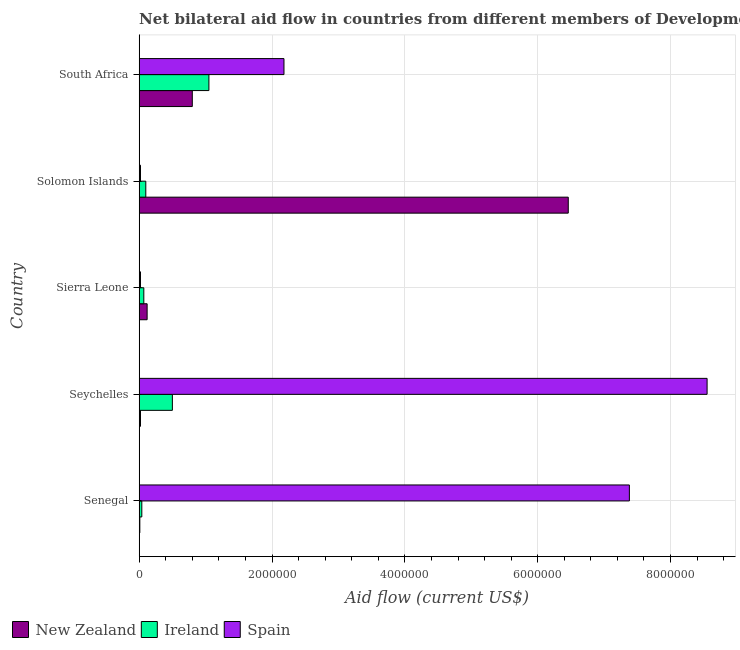How many different coloured bars are there?
Make the answer very short. 3. How many groups of bars are there?
Make the answer very short. 5. Are the number of bars per tick equal to the number of legend labels?
Provide a succinct answer. Yes. How many bars are there on the 4th tick from the bottom?
Provide a short and direct response. 3. What is the label of the 5th group of bars from the top?
Provide a short and direct response. Senegal. In how many cases, is the number of bars for a given country not equal to the number of legend labels?
Offer a terse response. 0. What is the amount of aid provided by new zealand in South Africa?
Your answer should be compact. 8.00e+05. Across all countries, what is the maximum amount of aid provided by new zealand?
Your answer should be very brief. 6.46e+06. Across all countries, what is the minimum amount of aid provided by new zealand?
Your answer should be compact. 10000. In which country was the amount of aid provided by spain maximum?
Give a very brief answer. Seychelles. In which country was the amount of aid provided by new zealand minimum?
Your answer should be compact. Senegal. What is the total amount of aid provided by spain in the graph?
Provide a succinct answer. 1.82e+07. What is the difference between the amount of aid provided by spain in Seychelles and that in Solomon Islands?
Offer a terse response. 8.53e+06. What is the difference between the amount of aid provided by new zealand in Seychelles and the amount of aid provided by spain in Sierra Leone?
Give a very brief answer. 0. What is the average amount of aid provided by ireland per country?
Your response must be concise. 3.52e+05. What is the difference between the amount of aid provided by ireland and amount of aid provided by new zealand in Solomon Islands?
Your answer should be very brief. -6.36e+06. In how many countries, is the amount of aid provided by new zealand greater than 6000000 US$?
Give a very brief answer. 1. What is the ratio of the amount of aid provided by spain in Senegal to that in Sierra Leone?
Your answer should be very brief. 369. Is the amount of aid provided by spain in Senegal less than that in South Africa?
Your answer should be very brief. No. Is the difference between the amount of aid provided by ireland in Senegal and Sierra Leone greater than the difference between the amount of aid provided by spain in Senegal and Sierra Leone?
Your response must be concise. No. What is the difference between the highest and the lowest amount of aid provided by ireland?
Provide a succinct answer. 1.01e+06. In how many countries, is the amount of aid provided by new zealand greater than the average amount of aid provided by new zealand taken over all countries?
Your answer should be compact. 1. What does the 1st bar from the top in Senegal represents?
Offer a terse response. Spain. What does the 1st bar from the bottom in Senegal represents?
Your answer should be compact. New Zealand. Is it the case that in every country, the sum of the amount of aid provided by new zealand and amount of aid provided by ireland is greater than the amount of aid provided by spain?
Offer a terse response. No. How many bars are there?
Provide a short and direct response. 15. Are all the bars in the graph horizontal?
Your response must be concise. Yes. How many countries are there in the graph?
Your answer should be compact. 5. What is the difference between two consecutive major ticks on the X-axis?
Offer a terse response. 2.00e+06. Are the values on the major ticks of X-axis written in scientific E-notation?
Make the answer very short. No. Where does the legend appear in the graph?
Keep it short and to the point. Bottom left. How are the legend labels stacked?
Your response must be concise. Horizontal. What is the title of the graph?
Provide a short and direct response. Net bilateral aid flow in countries from different members of Development Assistance Committee. Does "Ores and metals" appear as one of the legend labels in the graph?
Your answer should be very brief. No. What is the label or title of the X-axis?
Provide a short and direct response. Aid flow (current US$). What is the label or title of the Y-axis?
Your answer should be compact. Country. What is the Aid flow (current US$) in Spain in Senegal?
Make the answer very short. 7.38e+06. What is the Aid flow (current US$) in Ireland in Seychelles?
Your answer should be very brief. 5.00e+05. What is the Aid flow (current US$) in Spain in Seychelles?
Your answer should be very brief. 8.55e+06. What is the Aid flow (current US$) of New Zealand in Sierra Leone?
Offer a terse response. 1.20e+05. What is the Aid flow (current US$) of New Zealand in Solomon Islands?
Provide a short and direct response. 6.46e+06. What is the Aid flow (current US$) in Spain in Solomon Islands?
Your answer should be very brief. 2.00e+04. What is the Aid flow (current US$) in New Zealand in South Africa?
Make the answer very short. 8.00e+05. What is the Aid flow (current US$) of Ireland in South Africa?
Your answer should be very brief. 1.05e+06. What is the Aid flow (current US$) of Spain in South Africa?
Your answer should be very brief. 2.18e+06. Across all countries, what is the maximum Aid flow (current US$) of New Zealand?
Your response must be concise. 6.46e+06. Across all countries, what is the maximum Aid flow (current US$) in Ireland?
Your answer should be very brief. 1.05e+06. Across all countries, what is the maximum Aid flow (current US$) in Spain?
Give a very brief answer. 8.55e+06. Across all countries, what is the minimum Aid flow (current US$) of New Zealand?
Keep it short and to the point. 10000. Across all countries, what is the minimum Aid flow (current US$) of Ireland?
Provide a short and direct response. 4.00e+04. What is the total Aid flow (current US$) of New Zealand in the graph?
Make the answer very short. 7.41e+06. What is the total Aid flow (current US$) in Ireland in the graph?
Provide a succinct answer. 1.76e+06. What is the total Aid flow (current US$) in Spain in the graph?
Keep it short and to the point. 1.82e+07. What is the difference between the Aid flow (current US$) in Ireland in Senegal and that in Seychelles?
Your response must be concise. -4.60e+05. What is the difference between the Aid flow (current US$) in Spain in Senegal and that in Seychelles?
Give a very brief answer. -1.17e+06. What is the difference between the Aid flow (current US$) of Ireland in Senegal and that in Sierra Leone?
Your answer should be compact. -3.00e+04. What is the difference between the Aid flow (current US$) in Spain in Senegal and that in Sierra Leone?
Provide a short and direct response. 7.36e+06. What is the difference between the Aid flow (current US$) in New Zealand in Senegal and that in Solomon Islands?
Your answer should be compact. -6.45e+06. What is the difference between the Aid flow (current US$) in Spain in Senegal and that in Solomon Islands?
Give a very brief answer. 7.36e+06. What is the difference between the Aid flow (current US$) in New Zealand in Senegal and that in South Africa?
Make the answer very short. -7.90e+05. What is the difference between the Aid flow (current US$) of Ireland in Senegal and that in South Africa?
Ensure brevity in your answer.  -1.01e+06. What is the difference between the Aid flow (current US$) of Spain in Senegal and that in South Africa?
Offer a very short reply. 5.20e+06. What is the difference between the Aid flow (current US$) of New Zealand in Seychelles and that in Sierra Leone?
Make the answer very short. -1.00e+05. What is the difference between the Aid flow (current US$) in Spain in Seychelles and that in Sierra Leone?
Ensure brevity in your answer.  8.53e+06. What is the difference between the Aid flow (current US$) of New Zealand in Seychelles and that in Solomon Islands?
Your answer should be very brief. -6.44e+06. What is the difference between the Aid flow (current US$) of Ireland in Seychelles and that in Solomon Islands?
Offer a terse response. 4.00e+05. What is the difference between the Aid flow (current US$) in Spain in Seychelles and that in Solomon Islands?
Provide a short and direct response. 8.53e+06. What is the difference between the Aid flow (current US$) in New Zealand in Seychelles and that in South Africa?
Your response must be concise. -7.80e+05. What is the difference between the Aid flow (current US$) in Ireland in Seychelles and that in South Africa?
Make the answer very short. -5.50e+05. What is the difference between the Aid flow (current US$) of Spain in Seychelles and that in South Africa?
Provide a short and direct response. 6.37e+06. What is the difference between the Aid flow (current US$) of New Zealand in Sierra Leone and that in Solomon Islands?
Make the answer very short. -6.34e+06. What is the difference between the Aid flow (current US$) in Spain in Sierra Leone and that in Solomon Islands?
Your answer should be compact. 0. What is the difference between the Aid flow (current US$) in New Zealand in Sierra Leone and that in South Africa?
Your answer should be very brief. -6.80e+05. What is the difference between the Aid flow (current US$) in Ireland in Sierra Leone and that in South Africa?
Your answer should be very brief. -9.80e+05. What is the difference between the Aid flow (current US$) of Spain in Sierra Leone and that in South Africa?
Make the answer very short. -2.16e+06. What is the difference between the Aid flow (current US$) in New Zealand in Solomon Islands and that in South Africa?
Offer a very short reply. 5.66e+06. What is the difference between the Aid flow (current US$) of Ireland in Solomon Islands and that in South Africa?
Your answer should be very brief. -9.50e+05. What is the difference between the Aid flow (current US$) in Spain in Solomon Islands and that in South Africa?
Provide a succinct answer. -2.16e+06. What is the difference between the Aid flow (current US$) in New Zealand in Senegal and the Aid flow (current US$) in Ireland in Seychelles?
Provide a succinct answer. -4.90e+05. What is the difference between the Aid flow (current US$) in New Zealand in Senegal and the Aid flow (current US$) in Spain in Seychelles?
Ensure brevity in your answer.  -8.54e+06. What is the difference between the Aid flow (current US$) in Ireland in Senegal and the Aid flow (current US$) in Spain in Seychelles?
Ensure brevity in your answer.  -8.51e+06. What is the difference between the Aid flow (current US$) of New Zealand in Senegal and the Aid flow (current US$) of Ireland in Sierra Leone?
Your response must be concise. -6.00e+04. What is the difference between the Aid flow (current US$) of New Zealand in Senegal and the Aid flow (current US$) of Spain in Sierra Leone?
Your response must be concise. -10000. What is the difference between the Aid flow (current US$) in New Zealand in Senegal and the Aid flow (current US$) in Ireland in Solomon Islands?
Your response must be concise. -9.00e+04. What is the difference between the Aid flow (current US$) of New Zealand in Senegal and the Aid flow (current US$) of Ireland in South Africa?
Your answer should be very brief. -1.04e+06. What is the difference between the Aid flow (current US$) of New Zealand in Senegal and the Aid flow (current US$) of Spain in South Africa?
Your answer should be compact. -2.17e+06. What is the difference between the Aid flow (current US$) of Ireland in Senegal and the Aid flow (current US$) of Spain in South Africa?
Make the answer very short. -2.14e+06. What is the difference between the Aid flow (current US$) in New Zealand in Seychelles and the Aid flow (current US$) in Spain in Sierra Leone?
Make the answer very short. 0. What is the difference between the Aid flow (current US$) of New Zealand in Seychelles and the Aid flow (current US$) of Spain in Solomon Islands?
Make the answer very short. 0. What is the difference between the Aid flow (current US$) in Ireland in Seychelles and the Aid flow (current US$) in Spain in Solomon Islands?
Offer a very short reply. 4.80e+05. What is the difference between the Aid flow (current US$) in New Zealand in Seychelles and the Aid flow (current US$) in Ireland in South Africa?
Provide a succinct answer. -1.03e+06. What is the difference between the Aid flow (current US$) of New Zealand in Seychelles and the Aid flow (current US$) of Spain in South Africa?
Your answer should be compact. -2.16e+06. What is the difference between the Aid flow (current US$) of Ireland in Seychelles and the Aid flow (current US$) of Spain in South Africa?
Your answer should be very brief. -1.68e+06. What is the difference between the Aid flow (current US$) in New Zealand in Sierra Leone and the Aid flow (current US$) in Ireland in Solomon Islands?
Offer a terse response. 2.00e+04. What is the difference between the Aid flow (current US$) in New Zealand in Sierra Leone and the Aid flow (current US$) in Spain in Solomon Islands?
Your response must be concise. 1.00e+05. What is the difference between the Aid flow (current US$) in Ireland in Sierra Leone and the Aid flow (current US$) in Spain in Solomon Islands?
Ensure brevity in your answer.  5.00e+04. What is the difference between the Aid flow (current US$) of New Zealand in Sierra Leone and the Aid flow (current US$) of Ireland in South Africa?
Keep it short and to the point. -9.30e+05. What is the difference between the Aid flow (current US$) in New Zealand in Sierra Leone and the Aid flow (current US$) in Spain in South Africa?
Provide a succinct answer. -2.06e+06. What is the difference between the Aid flow (current US$) in Ireland in Sierra Leone and the Aid flow (current US$) in Spain in South Africa?
Offer a very short reply. -2.11e+06. What is the difference between the Aid flow (current US$) in New Zealand in Solomon Islands and the Aid flow (current US$) in Ireland in South Africa?
Give a very brief answer. 5.41e+06. What is the difference between the Aid flow (current US$) of New Zealand in Solomon Islands and the Aid flow (current US$) of Spain in South Africa?
Offer a very short reply. 4.28e+06. What is the difference between the Aid flow (current US$) of Ireland in Solomon Islands and the Aid flow (current US$) of Spain in South Africa?
Offer a very short reply. -2.08e+06. What is the average Aid flow (current US$) in New Zealand per country?
Ensure brevity in your answer.  1.48e+06. What is the average Aid flow (current US$) of Ireland per country?
Your answer should be very brief. 3.52e+05. What is the average Aid flow (current US$) of Spain per country?
Your answer should be compact. 3.63e+06. What is the difference between the Aid flow (current US$) in New Zealand and Aid flow (current US$) in Ireland in Senegal?
Offer a terse response. -3.00e+04. What is the difference between the Aid flow (current US$) of New Zealand and Aid flow (current US$) of Spain in Senegal?
Offer a terse response. -7.37e+06. What is the difference between the Aid flow (current US$) in Ireland and Aid flow (current US$) in Spain in Senegal?
Your response must be concise. -7.34e+06. What is the difference between the Aid flow (current US$) in New Zealand and Aid flow (current US$) in Ireland in Seychelles?
Ensure brevity in your answer.  -4.80e+05. What is the difference between the Aid flow (current US$) of New Zealand and Aid flow (current US$) of Spain in Seychelles?
Provide a short and direct response. -8.53e+06. What is the difference between the Aid flow (current US$) in Ireland and Aid flow (current US$) in Spain in Seychelles?
Ensure brevity in your answer.  -8.05e+06. What is the difference between the Aid flow (current US$) of New Zealand and Aid flow (current US$) of Ireland in Sierra Leone?
Your answer should be compact. 5.00e+04. What is the difference between the Aid flow (current US$) of New Zealand and Aid flow (current US$) of Spain in Sierra Leone?
Offer a terse response. 1.00e+05. What is the difference between the Aid flow (current US$) of Ireland and Aid flow (current US$) of Spain in Sierra Leone?
Make the answer very short. 5.00e+04. What is the difference between the Aid flow (current US$) in New Zealand and Aid flow (current US$) in Ireland in Solomon Islands?
Your answer should be very brief. 6.36e+06. What is the difference between the Aid flow (current US$) of New Zealand and Aid flow (current US$) of Spain in Solomon Islands?
Give a very brief answer. 6.44e+06. What is the difference between the Aid flow (current US$) in New Zealand and Aid flow (current US$) in Ireland in South Africa?
Give a very brief answer. -2.50e+05. What is the difference between the Aid flow (current US$) in New Zealand and Aid flow (current US$) in Spain in South Africa?
Offer a terse response. -1.38e+06. What is the difference between the Aid flow (current US$) of Ireland and Aid flow (current US$) of Spain in South Africa?
Provide a succinct answer. -1.13e+06. What is the ratio of the Aid flow (current US$) in New Zealand in Senegal to that in Seychelles?
Make the answer very short. 0.5. What is the ratio of the Aid flow (current US$) of Ireland in Senegal to that in Seychelles?
Your answer should be very brief. 0.08. What is the ratio of the Aid flow (current US$) in Spain in Senegal to that in Seychelles?
Offer a very short reply. 0.86. What is the ratio of the Aid flow (current US$) of New Zealand in Senegal to that in Sierra Leone?
Keep it short and to the point. 0.08. What is the ratio of the Aid flow (current US$) in Spain in Senegal to that in Sierra Leone?
Offer a terse response. 369. What is the ratio of the Aid flow (current US$) of New Zealand in Senegal to that in Solomon Islands?
Make the answer very short. 0. What is the ratio of the Aid flow (current US$) in Ireland in Senegal to that in Solomon Islands?
Provide a succinct answer. 0.4. What is the ratio of the Aid flow (current US$) of Spain in Senegal to that in Solomon Islands?
Your response must be concise. 369. What is the ratio of the Aid flow (current US$) of New Zealand in Senegal to that in South Africa?
Provide a succinct answer. 0.01. What is the ratio of the Aid flow (current US$) in Ireland in Senegal to that in South Africa?
Offer a very short reply. 0.04. What is the ratio of the Aid flow (current US$) in Spain in Senegal to that in South Africa?
Provide a short and direct response. 3.39. What is the ratio of the Aid flow (current US$) of New Zealand in Seychelles to that in Sierra Leone?
Provide a succinct answer. 0.17. What is the ratio of the Aid flow (current US$) in Ireland in Seychelles to that in Sierra Leone?
Provide a succinct answer. 7.14. What is the ratio of the Aid flow (current US$) of Spain in Seychelles to that in Sierra Leone?
Ensure brevity in your answer.  427.5. What is the ratio of the Aid flow (current US$) in New Zealand in Seychelles to that in Solomon Islands?
Provide a short and direct response. 0. What is the ratio of the Aid flow (current US$) in Ireland in Seychelles to that in Solomon Islands?
Offer a very short reply. 5. What is the ratio of the Aid flow (current US$) of Spain in Seychelles to that in Solomon Islands?
Give a very brief answer. 427.5. What is the ratio of the Aid flow (current US$) of New Zealand in Seychelles to that in South Africa?
Your response must be concise. 0.03. What is the ratio of the Aid flow (current US$) of Ireland in Seychelles to that in South Africa?
Give a very brief answer. 0.48. What is the ratio of the Aid flow (current US$) of Spain in Seychelles to that in South Africa?
Offer a very short reply. 3.92. What is the ratio of the Aid flow (current US$) of New Zealand in Sierra Leone to that in Solomon Islands?
Make the answer very short. 0.02. What is the ratio of the Aid flow (current US$) in Spain in Sierra Leone to that in Solomon Islands?
Provide a succinct answer. 1. What is the ratio of the Aid flow (current US$) in Ireland in Sierra Leone to that in South Africa?
Ensure brevity in your answer.  0.07. What is the ratio of the Aid flow (current US$) in Spain in Sierra Leone to that in South Africa?
Give a very brief answer. 0.01. What is the ratio of the Aid flow (current US$) of New Zealand in Solomon Islands to that in South Africa?
Give a very brief answer. 8.07. What is the ratio of the Aid flow (current US$) in Ireland in Solomon Islands to that in South Africa?
Your response must be concise. 0.1. What is the ratio of the Aid flow (current US$) of Spain in Solomon Islands to that in South Africa?
Give a very brief answer. 0.01. What is the difference between the highest and the second highest Aid flow (current US$) in New Zealand?
Provide a succinct answer. 5.66e+06. What is the difference between the highest and the second highest Aid flow (current US$) in Ireland?
Keep it short and to the point. 5.50e+05. What is the difference between the highest and the second highest Aid flow (current US$) in Spain?
Keep it short and to the point. 1.17e+06. What is the difference between the highest and the lowest Aid flow (current US$) of New Zealand?
Make the answer very short. 6.45e+06. What is the difference between the highest and the lowest Aid flow (current US$) of Ireland?
Give a very brief answer. 1.01e+06. What is the difference between the highest and the lowest Aid flow (current US$) of Spain?
Give a very brief answer. 8.53e+06. 